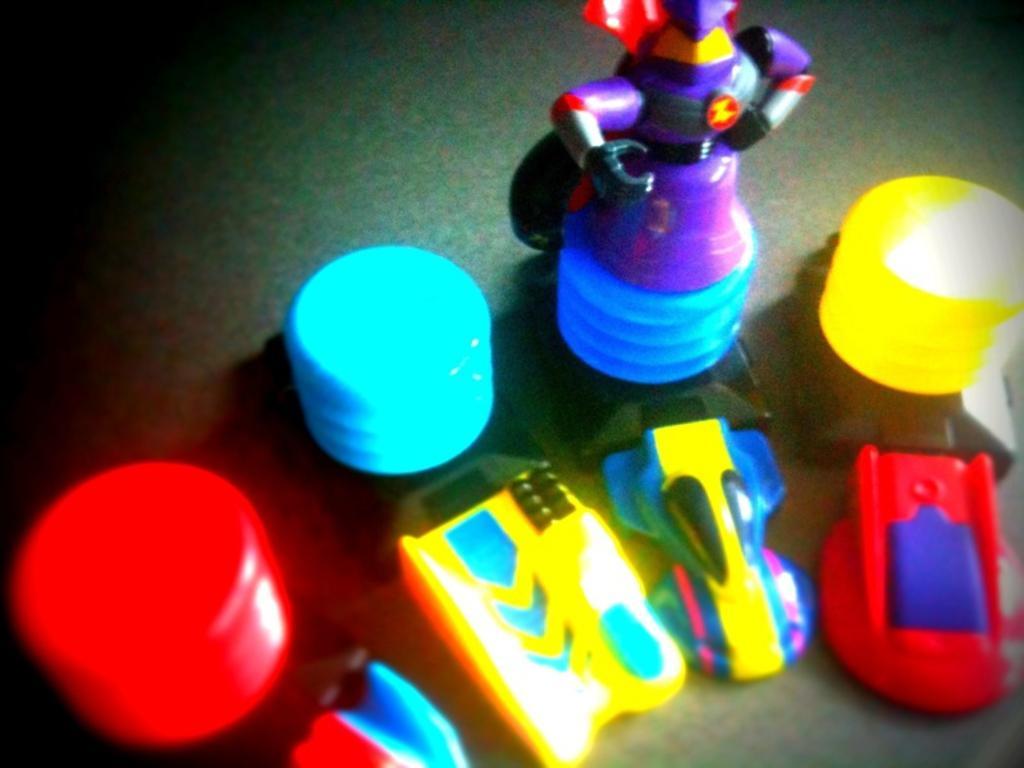Could you give a brief overview of what you see in this image? In this picture, it seems to be there are toy cars and other toys in the image. 